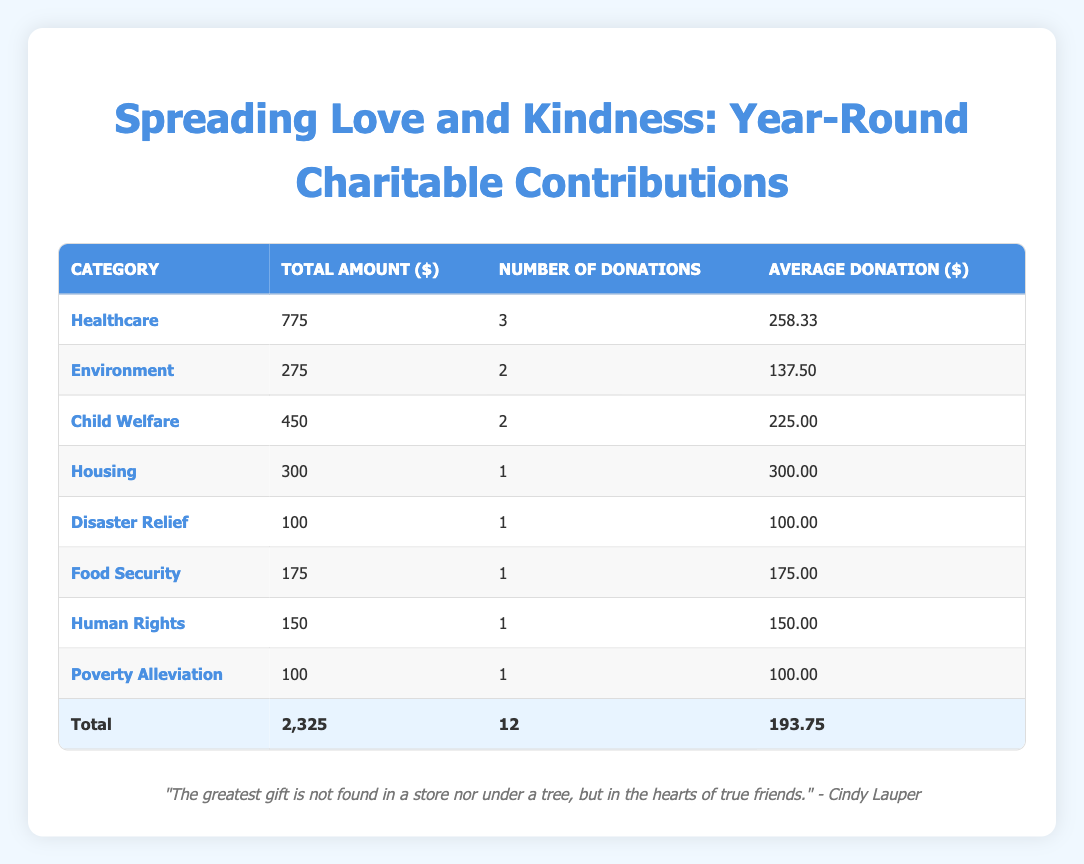What is the total amount donated to Healthcare causes? From the table, the total amount donated to Healthcare is the sum of the donations from Doctors Without Borders ($150), Alzheimer's Association ($125), and St. Jude Children's Research Hospital ($500). Adding these amounts gives us $150 + $125 + $500 = $775.
Answer: 775 How many donations were made to the Child Welfare category? The table shows two donations specifically categorized under Child Welfare: one from Save the Children and one from UNICEF. Thus, the number of donations made to this category is 2.
Answer: 2 What is the average donation amount across all categories? To find the average donation amount, we take the total amount donated ($2,325 from the total row) and divide it by the number of donations (12). Therefore, the average is calculated as $2,325 / 12 = $193.75.
Answer: 193.75 Is there any donation made for Disaster Relief? Looking at the table, there is indeed a donation listed under the Disaster Relief category: the American Red Cross donation of $100. Thus, the answer is yes.
Answer: Yes Which category received the highest average donation? To determine which category has the highest average donation, we need to calculate the average for each category: Healthcare ($775 / 3 = $258.33), Environment ($275 / 2 = $137.50), Child Welfare ($450 / 2 = $225.00), Housing ($300 / 1 = $300.00), Disaster Relief ($100 / 1 = $100.00), Food Security ($175 / 1 = $175.00), Human Rights ($150 / 1 = $150.00), and Poverty Alleviation ($100 / 1 = $100.00). The highest average donation is from Housing, at $300.
Answer: Housing How much was donated to Environmental causes compared to Disaster Relief? From the table, the amount donated to Environmental causes (World Wildlife Fund and The Nature Conservancy) totals $275, and the donation for Disaster Relief (American Red Cross) is $100. Therefore, the amount donated to Environmental causes is $275 - $100 = $175 more than the amount donated to Disaster Relief.
Answer: 175 more 